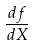<formula> <loc_0><loc_0><loc_500><loc_500>\frac { d f } { d X }</formula> 